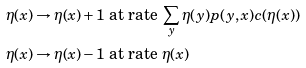Convert formula to latex. <formula><loc_0><loc_0><loc_500><loc_500>\eta ( x ) \to \eta ( x ) + 1 & \text { at rate } \sum _ { y } \eta ( y ) p ( y , x ) c ( \eta ( x ) ) \\ \eta ( x ) \to \eta ( x ) - 1 & \text { at rate } \eta ( x )</formula> 